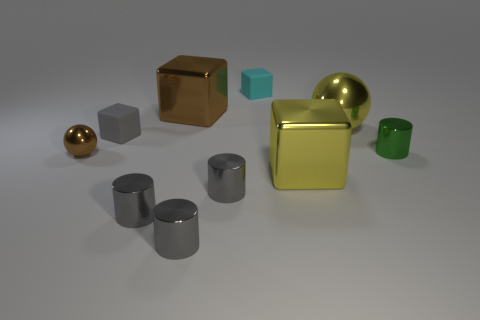What number of other large metallic objects are the same shape as the cyan thing?
Offer a very short reply. 2. Is the number of yellow spheres that are in front of the brown sphere less than the number of gray rubber blocks behind the small green object?
Ensure brevity in your answer.  Yes. There is a rubber thing behind the yellow shiny ball; how many small rubber objects are right of it?
Offer a very short reply. 0. Is there a tiny gray ball?
Your answer should be very brief. No. Is there a brown block that has the same material as the green cylinder?
Your response must be concise. Yes. Is the number of metal objects that are to the right of the yellow cube greater than the number of small green metal things that are in front of the small brown metallic object?
Your response must be concise. Yes. Is the size of the yellow metal ball the same as the yellow block?
Ensure brevity in your answer.  Yes. There is a large metal block in front of the green thing right of the brown sphere; what is its color?
Your answer should be very brief. Yellow. What is the color of the large metal ball?
Make the answer very short. Yellow. Is there a metallic block of the same color as the small sphere?
Your answer should be very brief. Yes. 